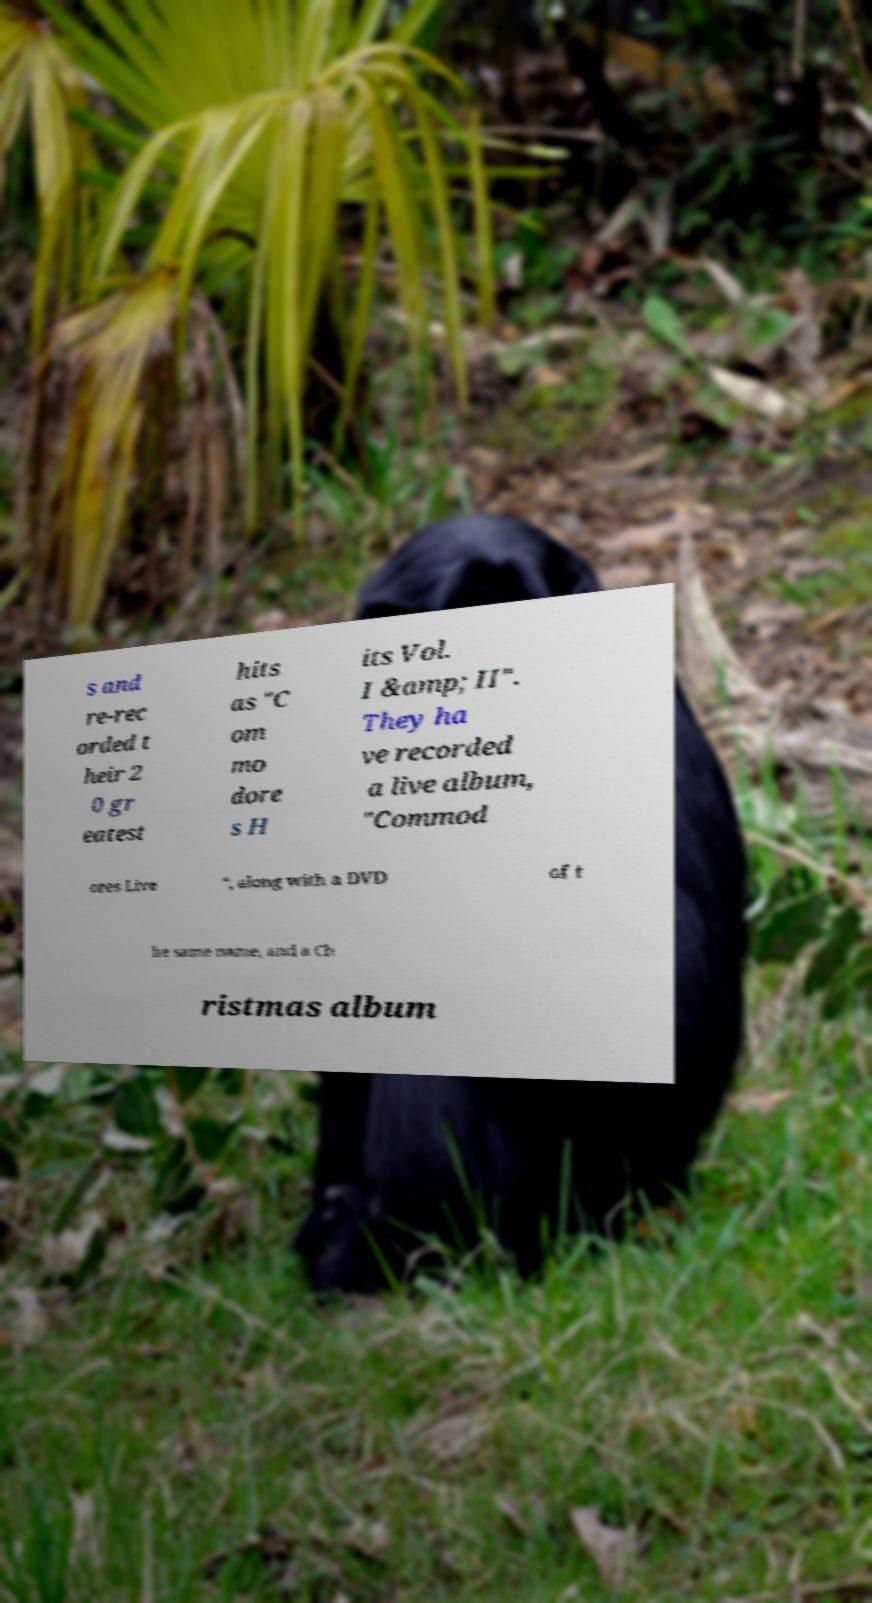Please read and relay the text visible in this image. What does it say? s and re-rec orded t heir 2 0 gr eatest hits as "C om mo dore s H its Vol. I &amp; II". They ha ve recorded a live album, "Commod ores Live ", along with a DVD of t he same name, and a Ch ristmas album 